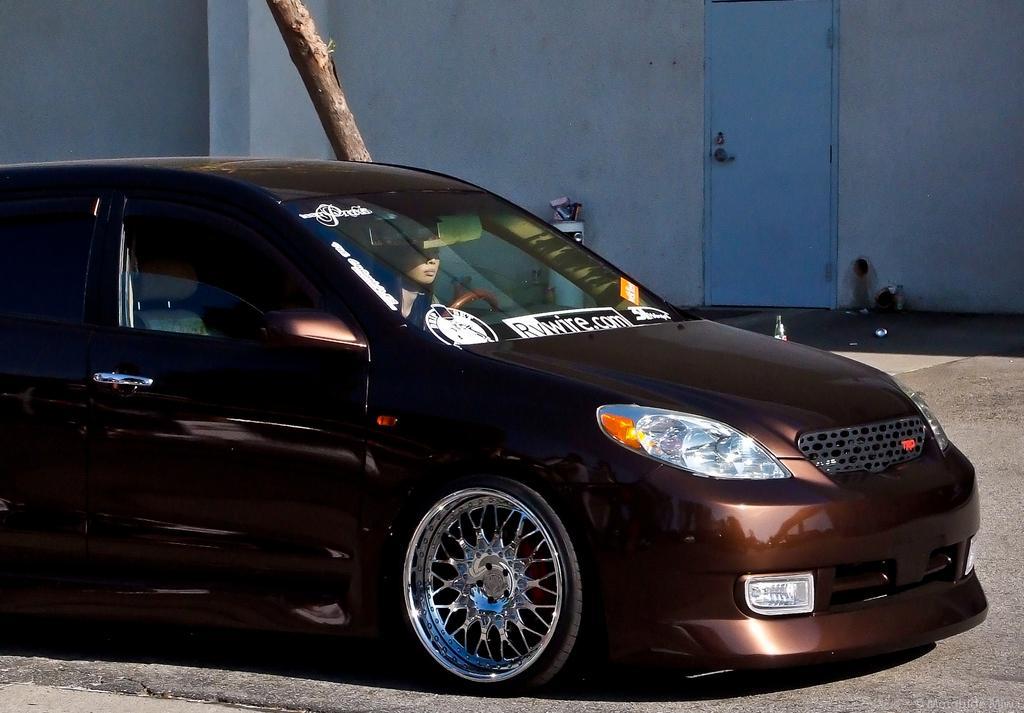Describe this image in one or two sentences. In this image in the center there is one car and one woman sitting in a car, and in the background there is a wooden stick, wall and one door. At the bottom there is a road. 